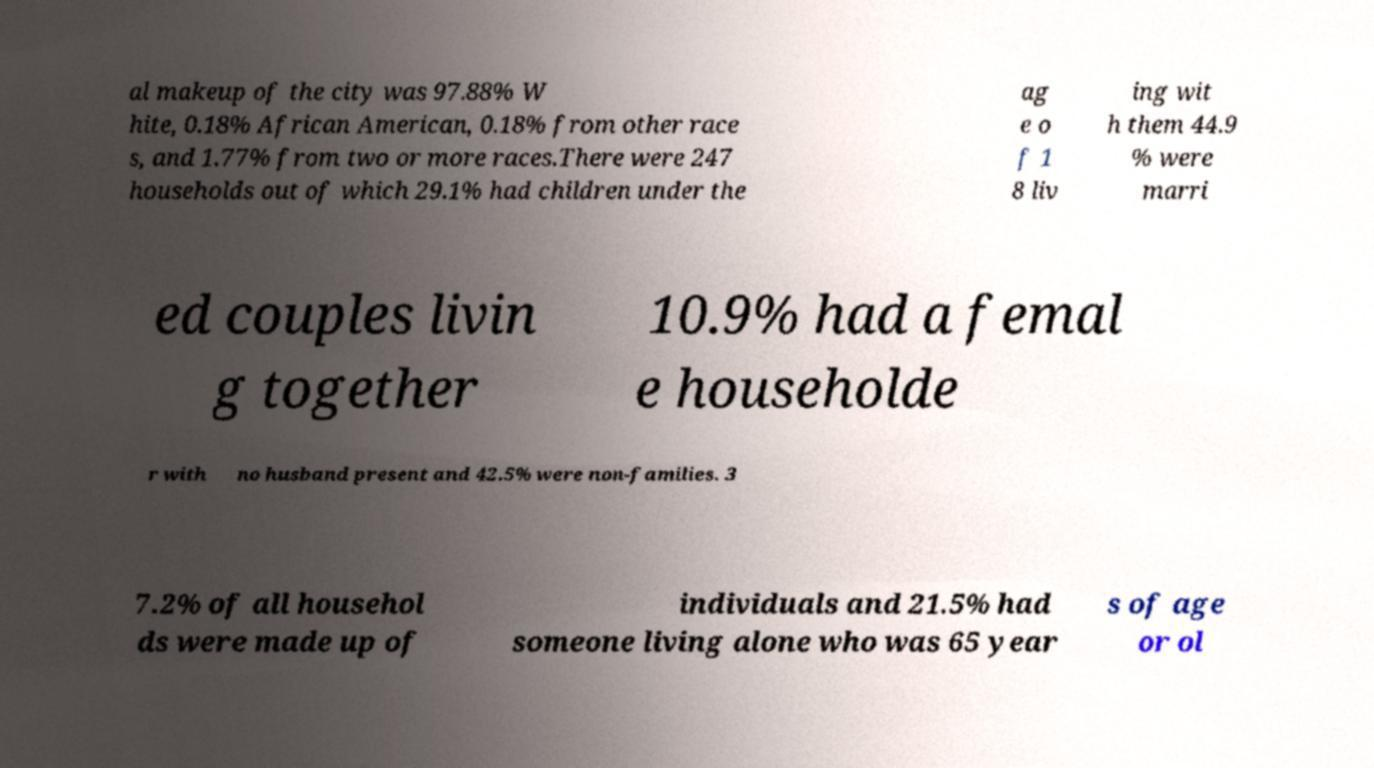What messages or text are displayed in this image? I need them in a readable, typed format. al makeup of the city was 97.88% W hite, 0.18% African American, 0.18% from other race s, and 1.77% from two or more races.There were 247 households out of which 29.1% had children under the ag e o f 1 8 liv ing wit h them 44.9 % were marri ed couples livin g together 10.9% had a femal e householde r with no husband present and 42.5% were non-families. 3 7.2% of all househol ds were made up of individuals and 21.5% had someone living alone who was 65 year s of age or ol 